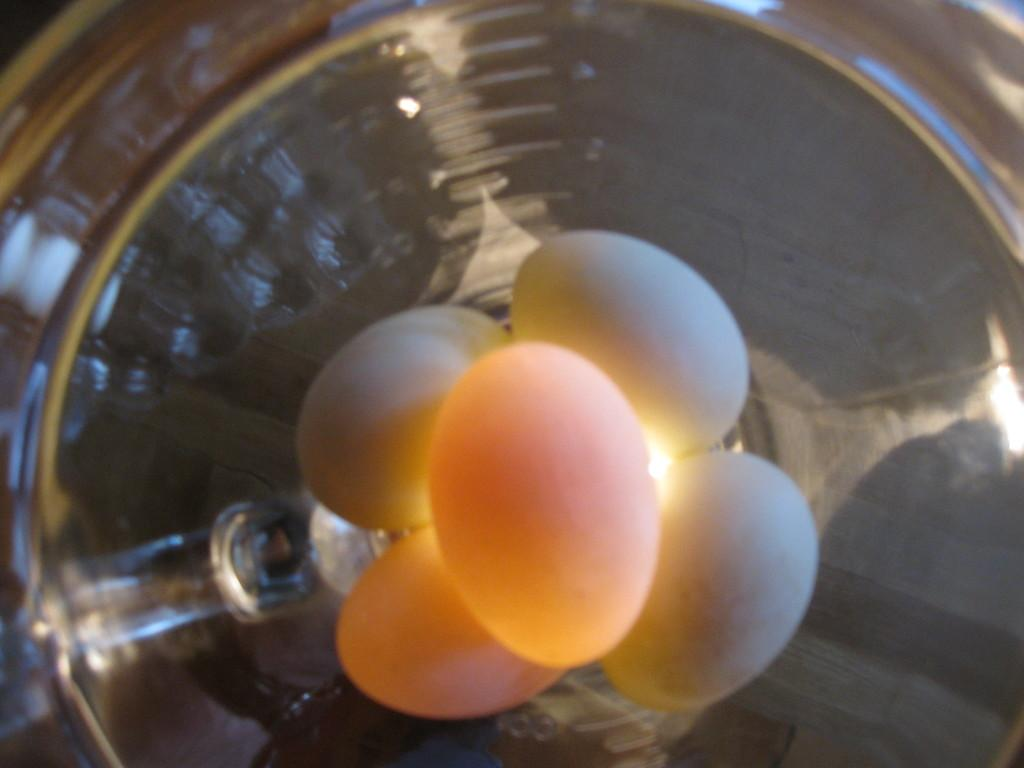What is present in the image? There are eggs in the image. How are the eggs arranged or contained? The eggs are in a container. What color are the eyes of the person holding the basket in the image? There is no person holding a basket in the image, and therefore no eyes to observe. 